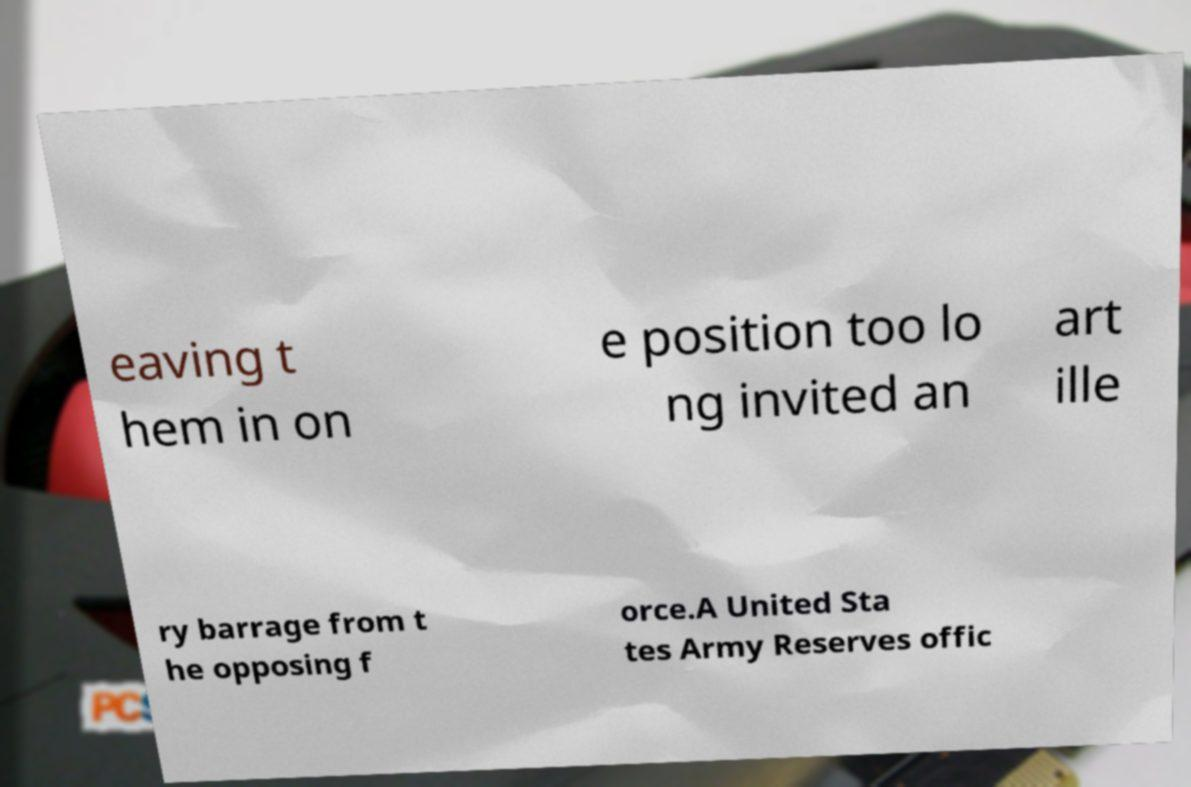What messages or text are displayed in this image? I need them in a readable, typed format. eaving t hem in on e position too lo ng invited an art ille ry barrage from t he opposing f orce.A United Sta tes Army Reserves offic 